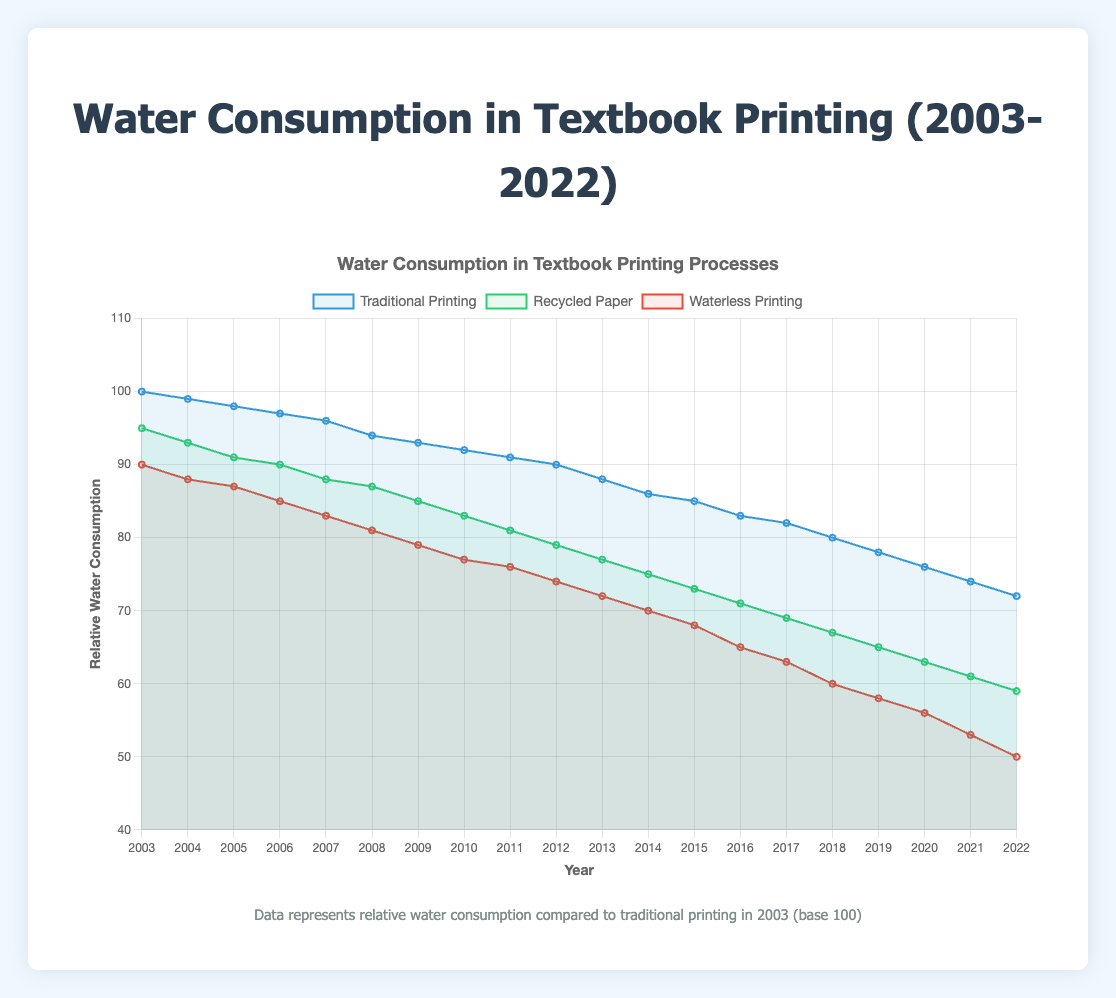Which year shows the greatest reduction in water consumption for traditional printing compared to 2003? In 2003, the water consumption for traditional printing is 100. Each subsequent year decreases slightly. By 2022, it drops to 72, representing the greatest reduction.
Answer: 2022 What is the difference in water consumption between traditional printing and waterless printing in 2010? In 2010, traditional printing uses 92 units of water and waterless printing uses 77 units. The difference is 92 - 77.
Answer: 15 By how many units did the water consumption for recycled paper printing decrease from 2003 to 2022? In 2003, recycled paper printing used 95 units of water. By 2022, it uses 59 units. The decrease is 95 - 59.
Answer: 36 Which printing method showed the smallest annual reduction in water consumption between 2003 and 2004? Traditional printing reduced by 1 unit (100 to 99), recycled paper by 2 units (95 to 93), and waterless printing by 2 units (90 to 88). Therefore, traditional printing showed the smallest reduction.
Answer: Traditional printing What is the average water consumption for waterless printing over the entire 20-year period? Sum the water consumption for waterless printing from 2003 to 2022 and divide by 20. The sum is (90 + 88 + 87 + 85 + 83 + 81 + 79 + 77 + 76 + 74 + 72 + 70 + 68 + 65 + 63 + 60 + 58 + 56 + 53 + 50) = 1367. Average is 1367/20.
Answer: 68.35 In which year did recycled paper printing first use less than 80 units of water? From the plot, the water consumption for recycled paper printing drops below 80 units in 2012, reaching 79 units.
Answer: 2012 How much more water did traditional printing use in 2022 compared to waterless printing in the same year? In 2022, traditional printing used 72 units of water, and waterless printing used 50 units. The difference is 72 - 50.
Answer: 22 Which printing method showed the fastest decline in water consumption from 2011 to 2012? From 2011 to 2012, traditional printing reduced by 1 unit (91 to 90), recycled paper by 2 units (81 to 79), and waterless printing by 2 units (76 to 74). Since recycled paper and waterless printing both reduced by 2 units but are the same, either can be considered the fastest.
Answer: Recycled paper and waterless printing By 2022, how many units of water does traditional printing use relative to 2003? In 2022, traditional printing uses 72 units of water compared to 100 in 2003. Thus, it uses 72 units relative to the base year.
Answer: 72 